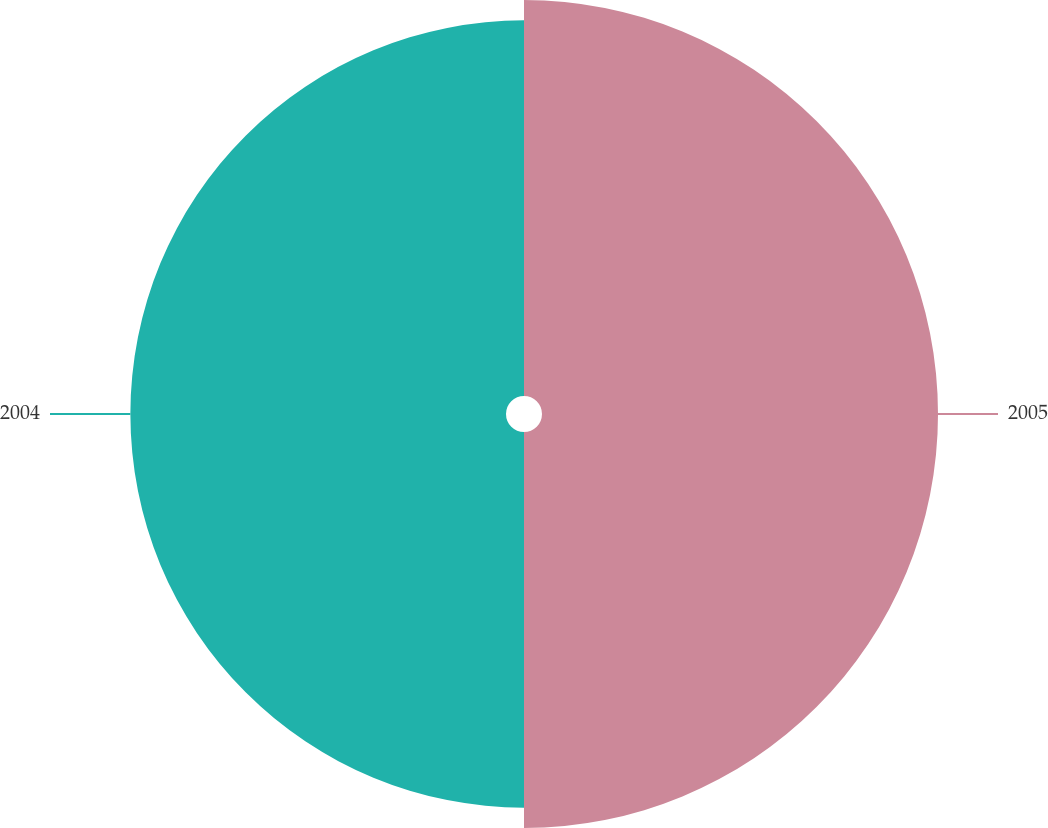Convert chart to OTSL. <chart><loc_0><loc_0><loc_500><loc_500><pie_chart><fcel>2005<fcel>2004<nl><fcel>51.32%<fcel>48.68%<nl></chart> 